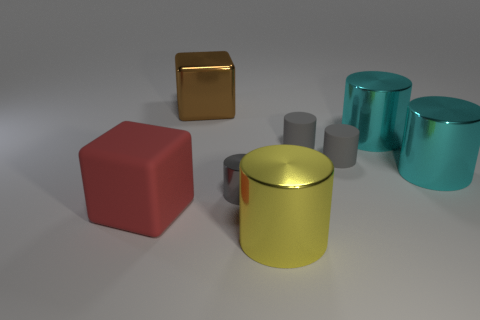Subtract all cyan metallic cylinders. How many cylinders are left? 4 Add 1 brown metallic cubes. How many objects exist? 9 Subtract all red blocks. How many blocks are left? 1 Subtract all brown cubes. How many gray cylinders are left? 3 Subtract all blocks. How many objects are left? 6 Subtract 0 brown spheres. How many objects are left? 8 Subtract all brown cylinders. Subtract all purple cubes. How many cylinders are left? 6 Subtract all tiny gray things. Subtract all big matte blocks. How many objects are left? 4 Add 1 small objects. How many small objects are left? 4 Add 2 yellow metal objects. How many yellow metal objects exist? 3 